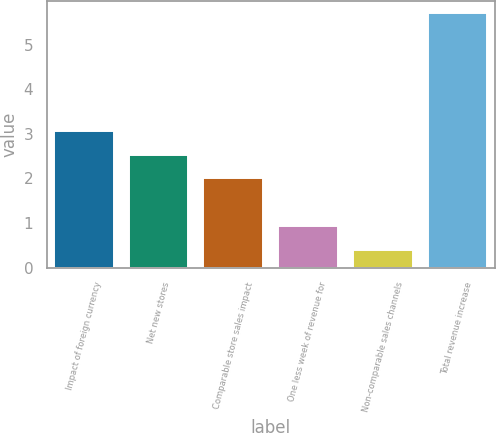<chart> <loc_0><loc_0><loc_500><loc_500><bar_chart><fcel>Impact of foreign currency<fcel>Net new stores<fcel>Comparable store sales impact<fcel>One less week of revenue for<fcel>Non-comparable sales channels<fcel>Total revenue increase<nl><fcel>3.06<fcel>2.53<fcel>2<fcel>0.93<fcel>0.4<fcel>5.7<nl></chart> 